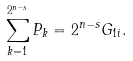Convert formula to latex. <formula><loc_0><loc_0><loc_500><loc_500>\sum _ { k = 1 } ^ { 2 ^ { n - s } } P _ { k } = 2 ^ { n - s } G _ { 1 i } .</formula> 